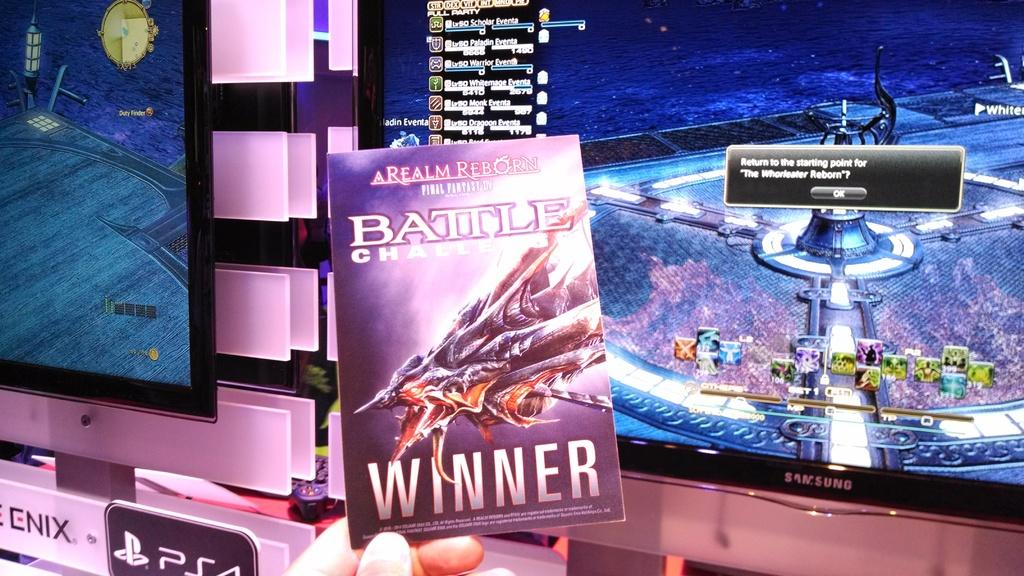<image>
Present a compact description of the photo's key features. A book titled Battle Challe  Winner being held up by two fingers. 